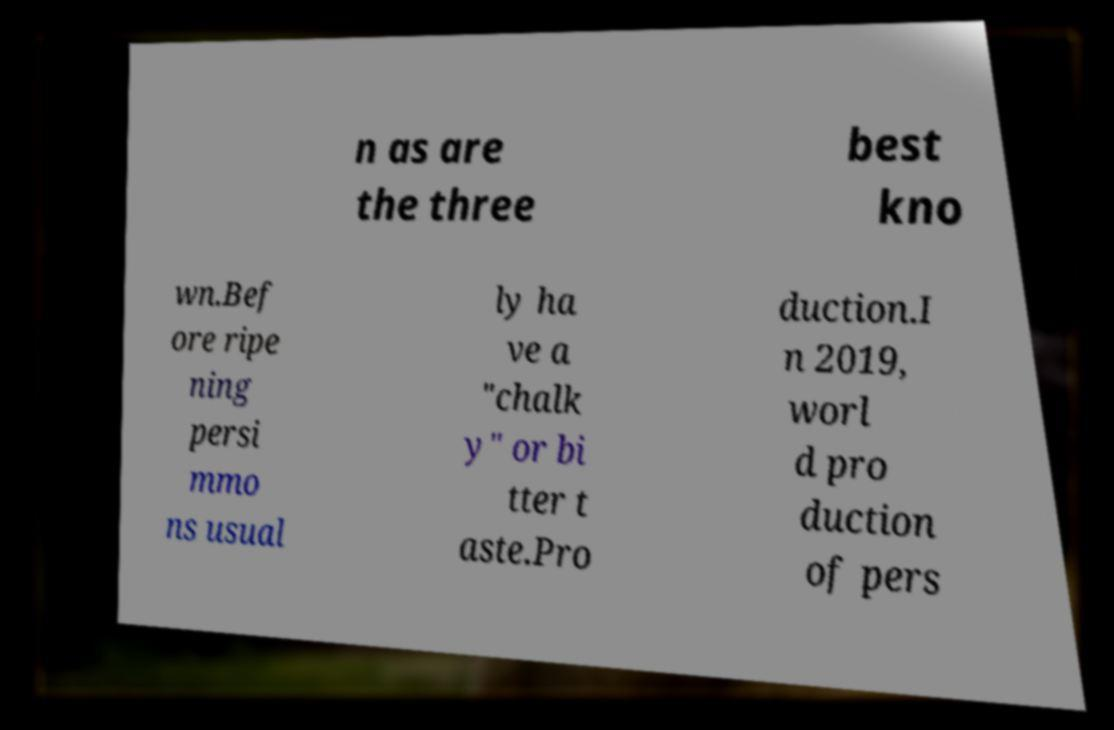Could you extract and type out the text from this image? n as are the three best kno wn.Bef ore ripe ning persi mmo ns usual ly ha ve a "chalk y" or bi tter t aste.Pro duction.I n 2019, worl d pro duction of pers 